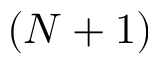<formula> <loc_0><loc_0><loc_500><loc_500>( N + 1 )</formula> 